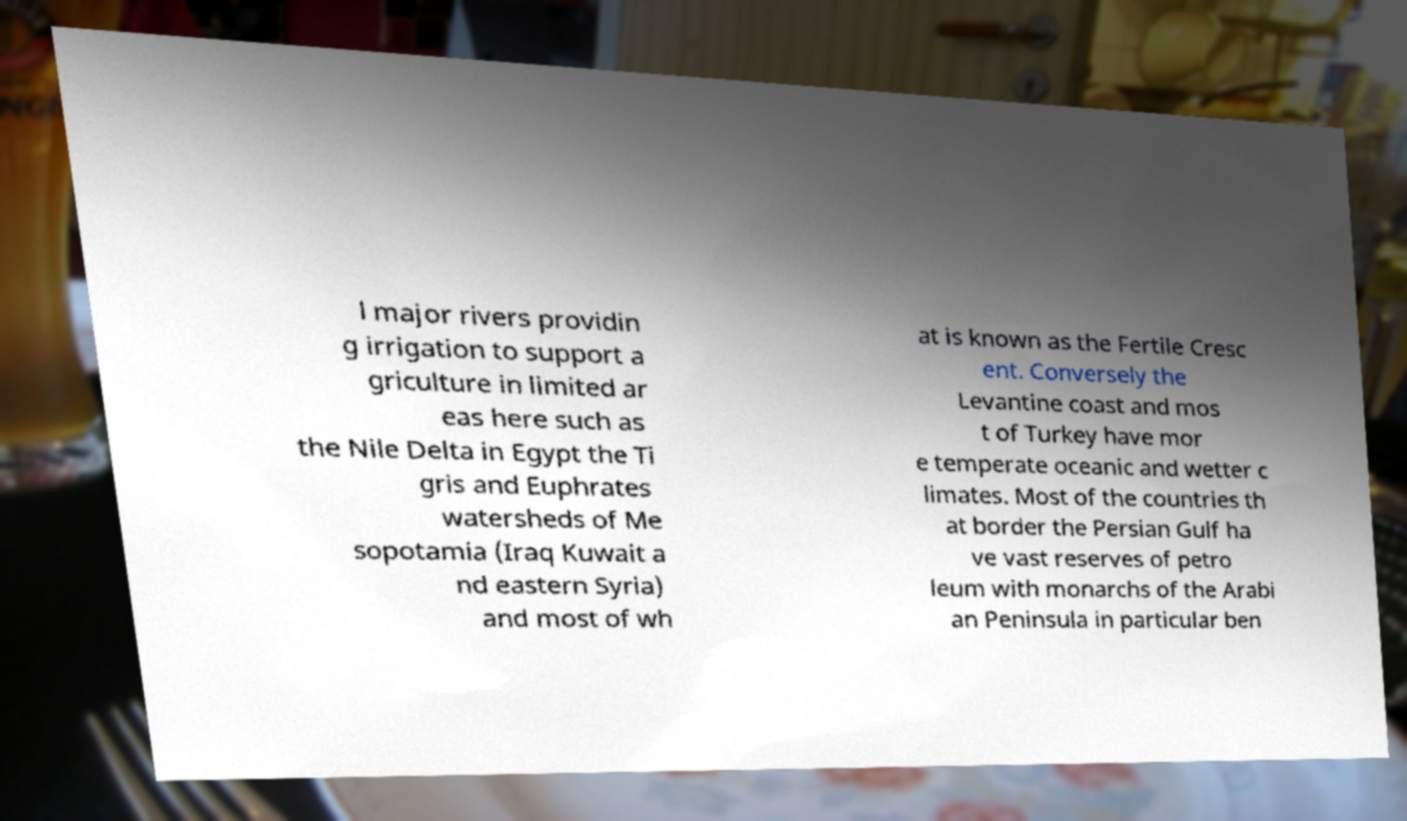Could you extract and type out the text from this image? l major rivers providin g irrigation to support a griculture in limited ar eas here such as the Nile Delta in Egypt the Ti gris and Euphrates watersheds of Me sopotamia (Iraq Kuwait a nd eastern Syria) and most of wh at is known as the Fertile Cresc ent. Conversely the Levantine coast and mos t of Turkey have mor e temperate oceanic and wetter c limates. Most of the countries th at border the Persian Gulf ha ve vast reserves of petro leum with monarchs of the Arabi an Peninsula in particular ben 